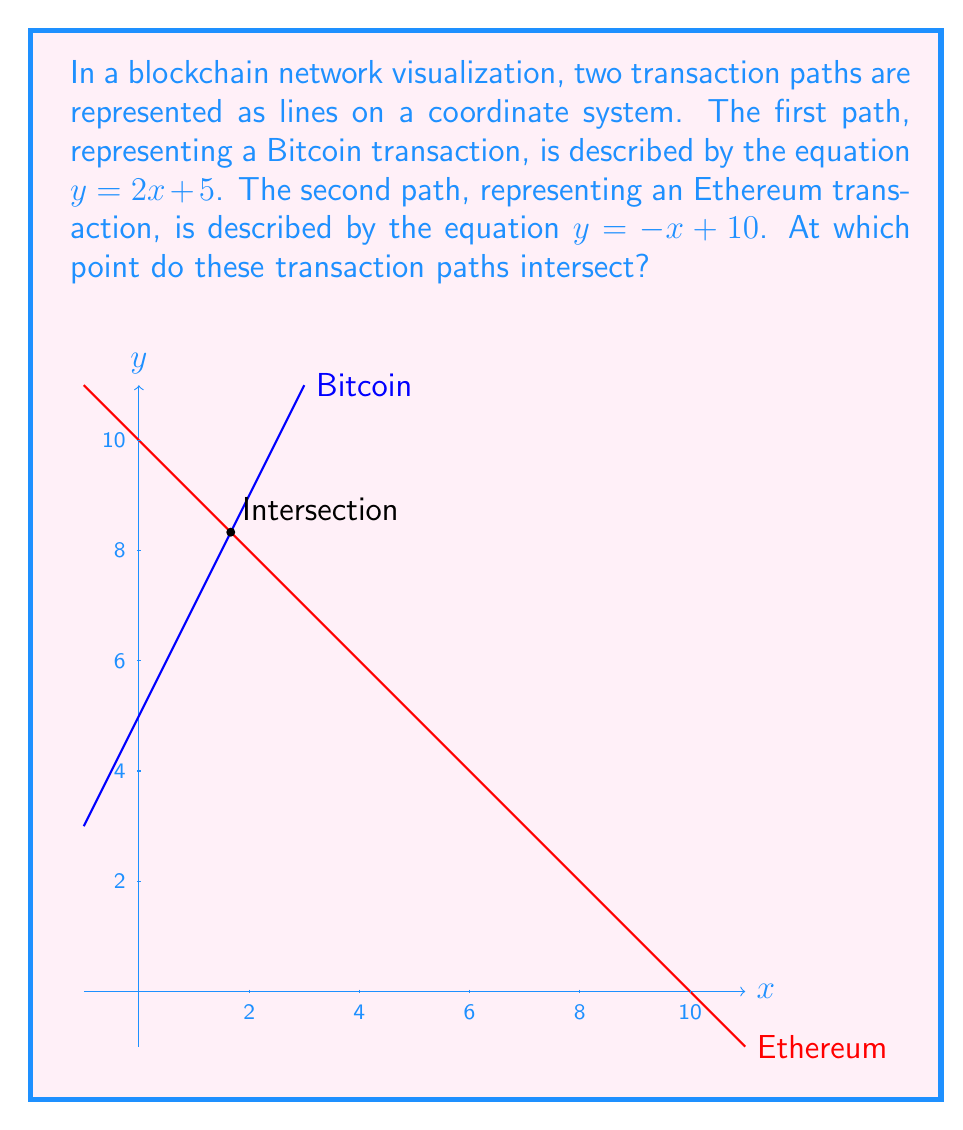Provide a solution to this math problem. To find the intersection point of these two lines, we need to solve the system of equations:

$$\begin{cases}
y = 2x + 5 \\
y = -x + 10
\end{cases}$$

Since both equations are equal to y, we can set them equal to each other:

$$2x + 5 = -x + 10$$

Now, let's solve for x:

1) Add x to both sides:
   $$3x + 5 = 10$$

2) Subtract 5 from both sides:
   $$3x = 5$$

3) Divide both sides by 3:
   $$x = \frac{5}{3}$$

Now that we have the x-coordinate, we can substitute it into either of the original equations to find y. Let's use the first equation:

$$y = 2(\frac{5}{3}) + 5$$

$$y = \frac{10}{3} + 5$$

$$y = \frac{10}{3} + \frac{15}{3} = \frac{25}{3}$$

Therefore, the intersection point is $(\frac{5}{3}, \frac{25}{3})$.
Answer: $(\frac{5}{3}, \frac{25}{3})$ 